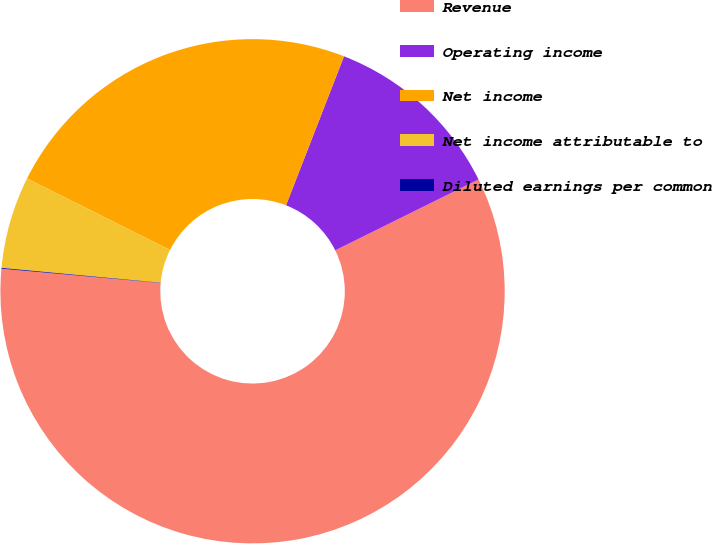Convert chart. <chart><loc_0><loc_0><loc_500><loc_500><pie_chart><fcel>Revenue<fcel>Operating income<fcel>Net income<fcel>Net income attributable to<fcel>Diluted earnings per common<nl><fcel>58.74%<fcel>11.78%<fcel>23.52%<fcel>5.91%<fcel>0.05%<nl></chart> 